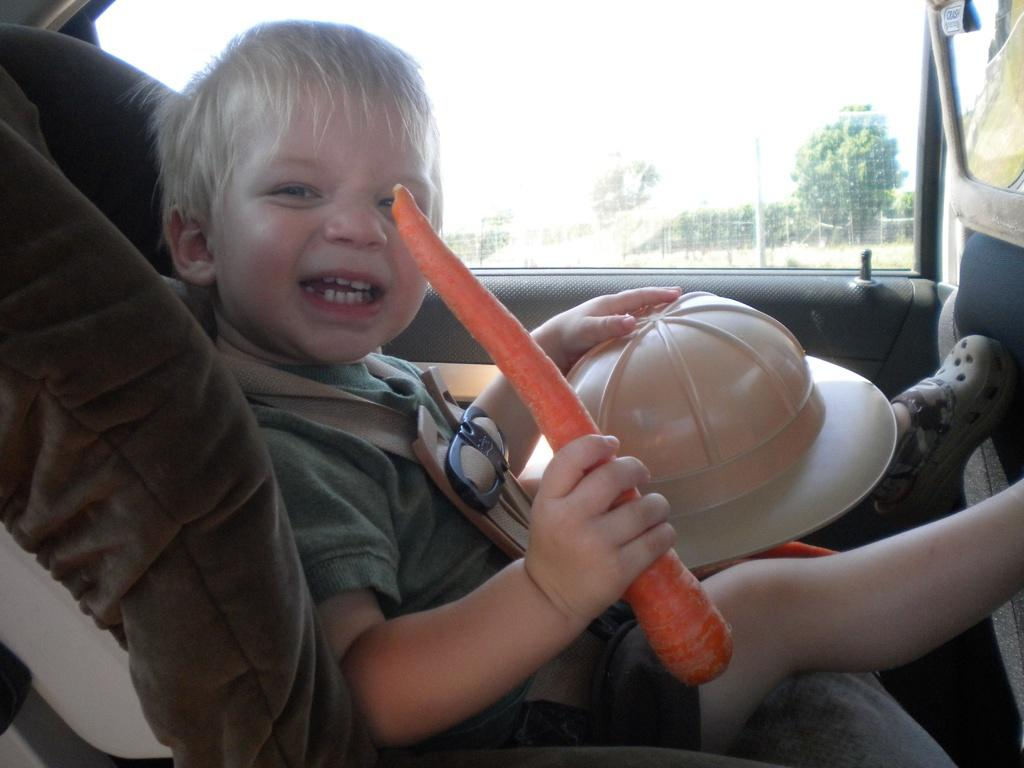Who is in the image? There is a boy in the image. What is the boy holding in his hands? The boy is holding a cap and a carrot. What is the boy sitting on? The boy is sitting on a chair. What can be seen in the background of the image? There is a window in the background of the image, and trees and a pole are visible through the window. What type of knife is the boy using to cut the carrot in the image? There is no knife present in the image; the boy is holding a cap and a carrot. What medical condition is the boy being treated for in the hospital in the image? There is no hospital or medical condition mentioned in the image; it features a boy sitting on a chair holding a cap and a carrot. 